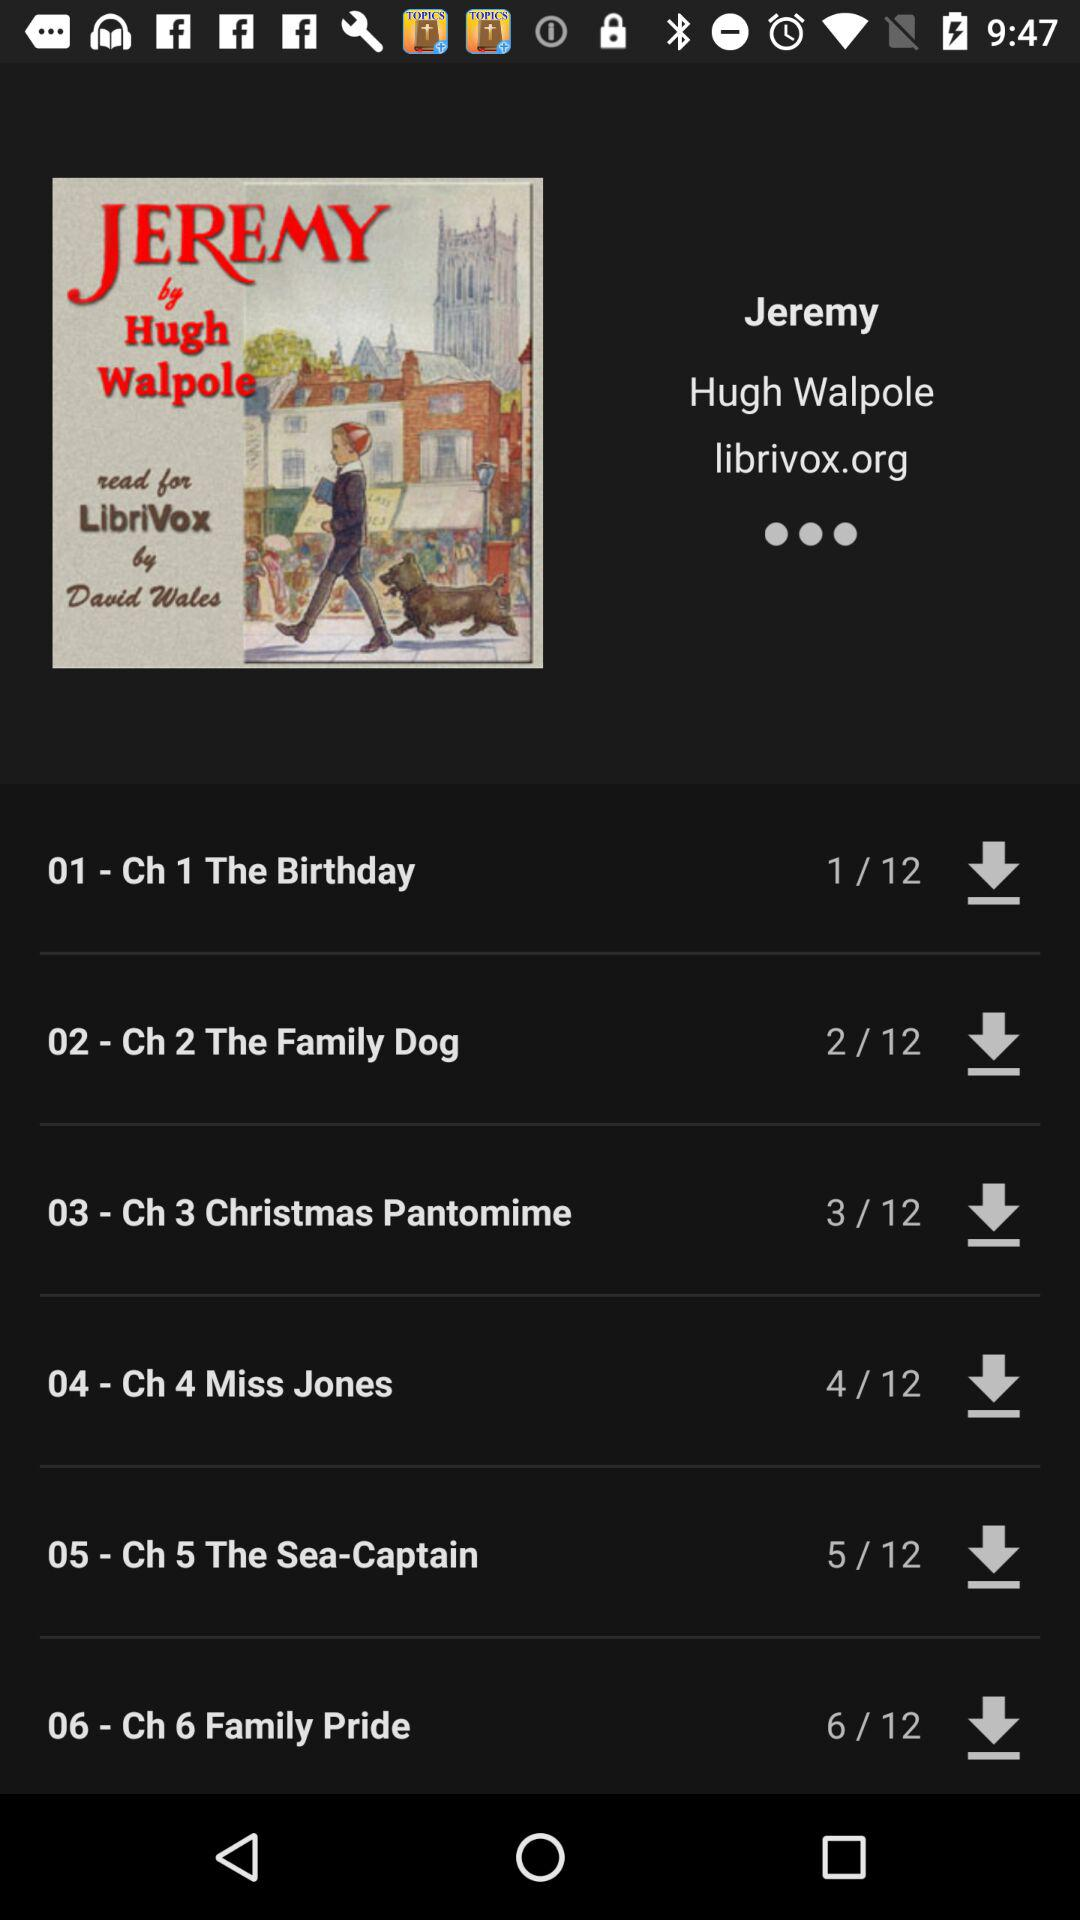How many total chapters are there in this book? There are 12 chapters. 